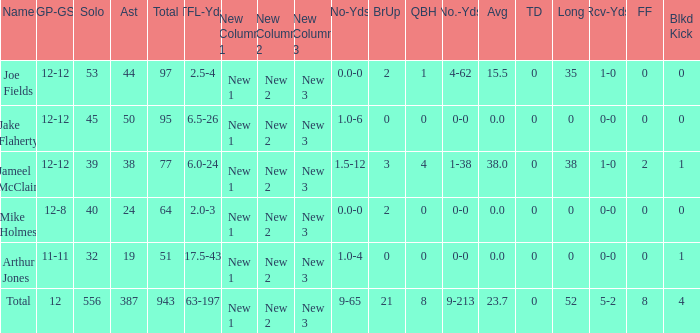How many tackle assists for the player who averages 23.7? 387.0. 